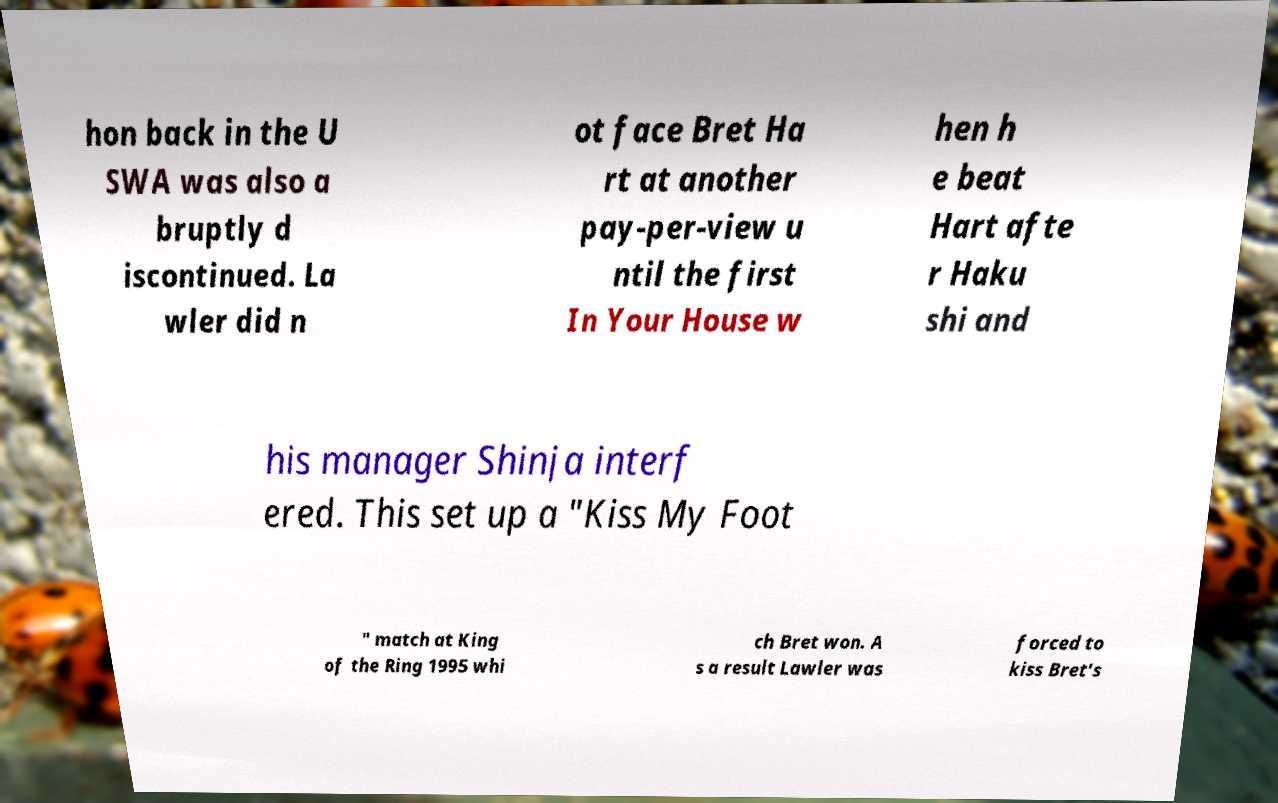I need the written content from this picture converted into text. Can you do that? hon back in the U SWA was also a bruptly d iscontinued. La wler did n ot face Bret Ha rt at another pay-per-view u ntil the first In Your House w hen h e beat Hart afte r Haku shi and his manager Shinja interf ered. This set up a "Kiss My Foot " match at King of the Ring 1995 whi ch Bret won. A s a result Lawler was forced to kiss Bret's 